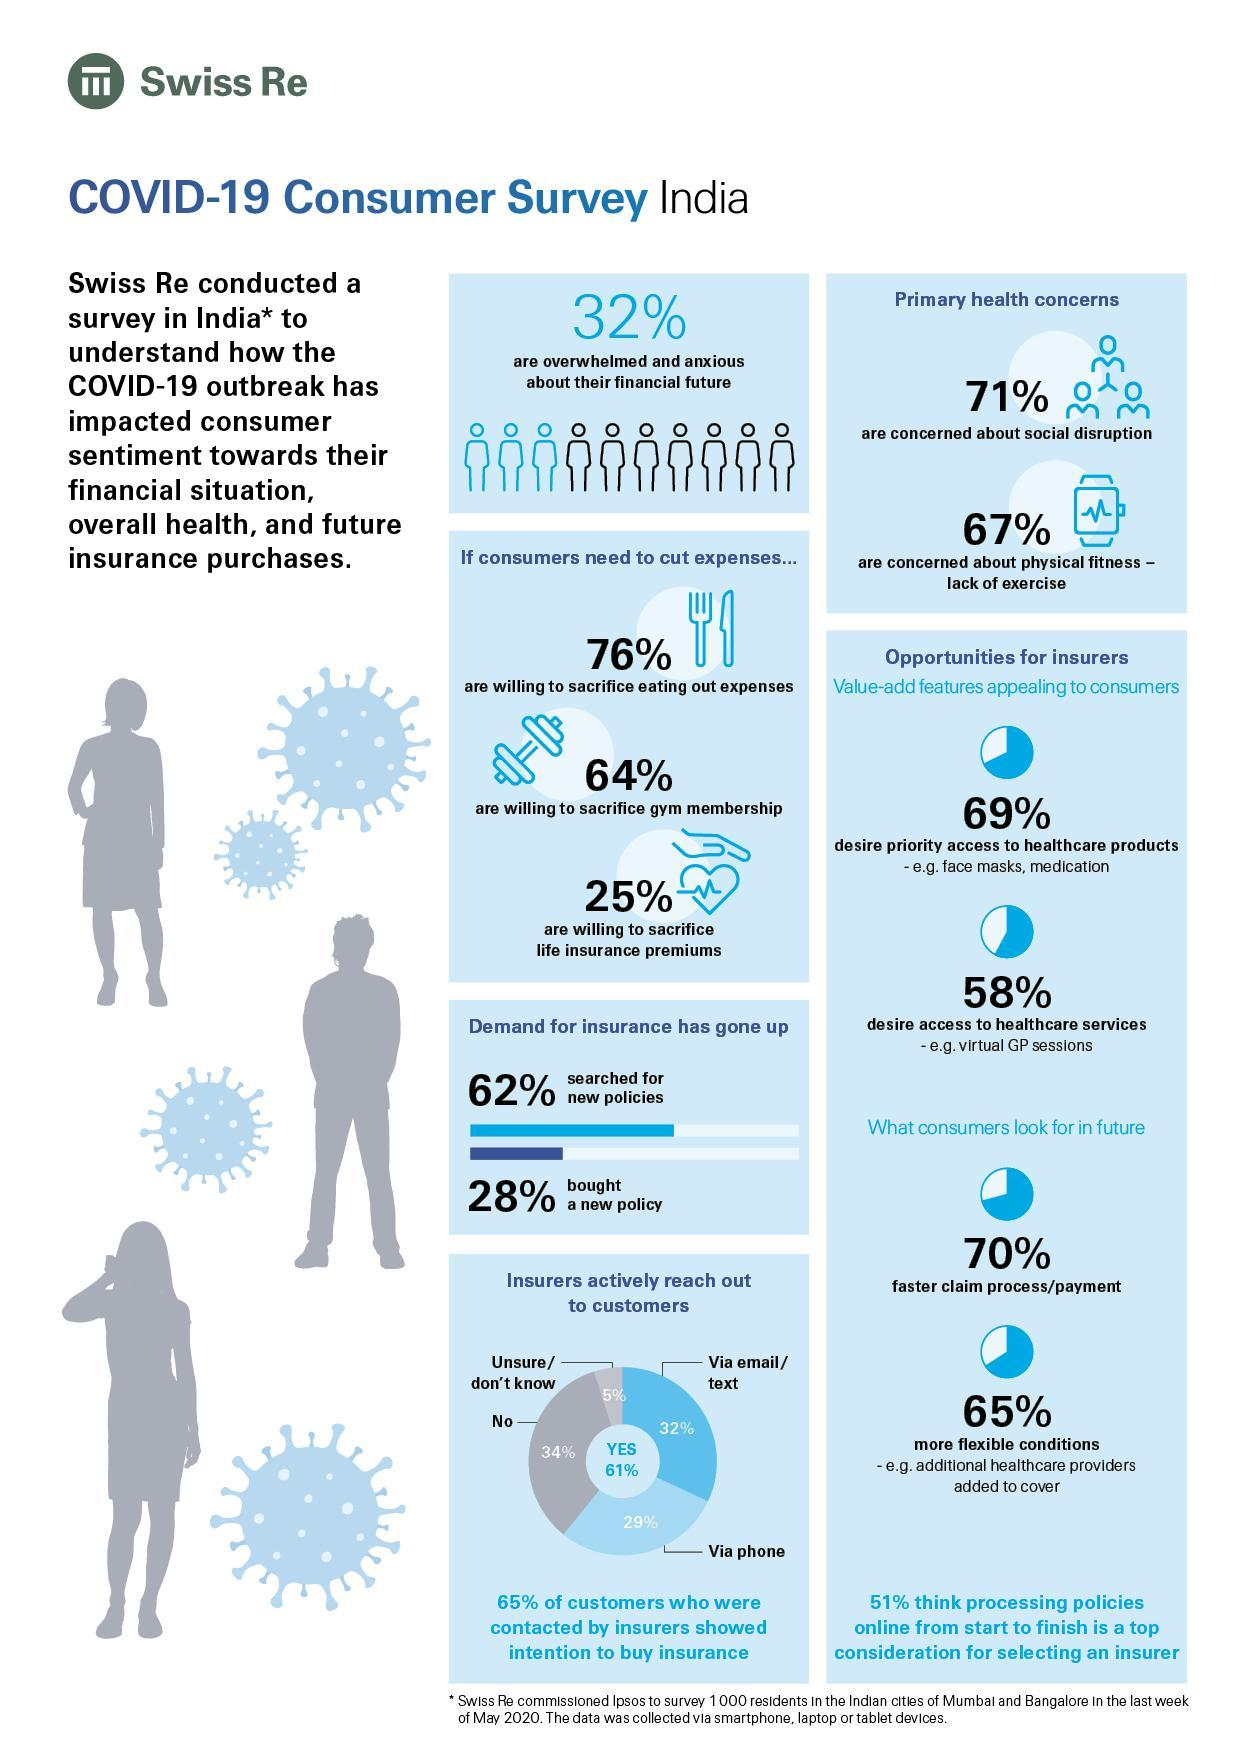What percentage of people are not willing to sacrifice life insurance premiums?
Answer the question with a short phrase. 75% What percentage of consumers look for a faster claim process? 70% What percentage of people are not willing to sacrifice eating out expenses? 24% What percentage of consumers look for more flexible conditions? 65% What percentage of people are not concerned about social disruption? 29% What percentage of people are not willing to sacrifice gym membership? 36% What percentage of people are not concerned about physical fitness? 33% What percentage of people are not overwhelmed and anxious about their financial future? 68% 